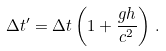<formula> <loc_0><loc_0><loc_500><loc_500>\Delta t ^ { \prime } = \Delta t \left ( 1 + \frac { g h } { c ^ { 2 } } \right ) \, .</formula> 